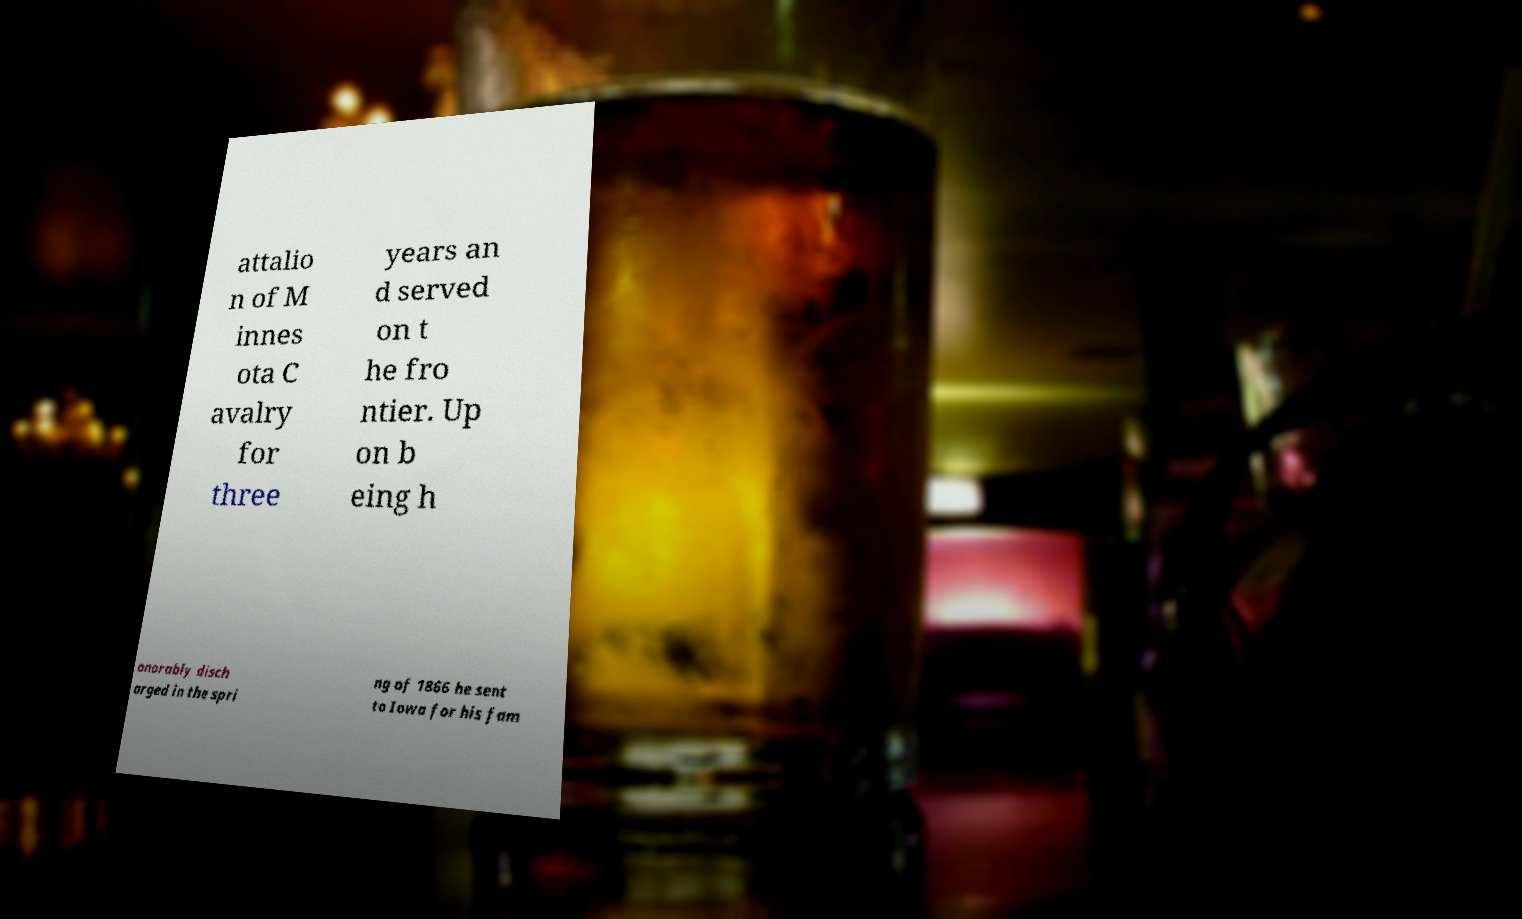Can you accurately transcribe the text from the provided image for me? attalio n of M innes ota C avalry for three years an d served on t he fro ntier. Up on b eing h onorably disch arged in the spri ng of 1866 he sent to Iowa for his fam 